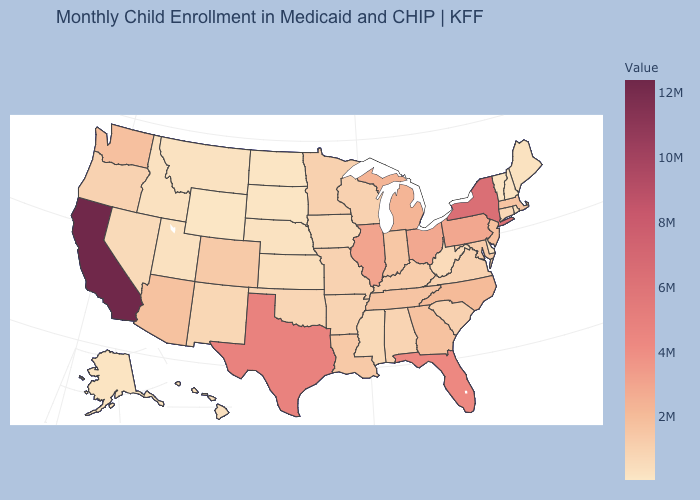Is the legend a continuous bar?
Give a very brief answer. Yes. Does Illinois have the highest value in the MidWest?
Keep it brief. Yes. Which states have the lowest value in the USA?
Quick response, please. Wyoming. Does Maine have a lower value than New Jersey?
Be succinct. Yes. Does Kentucky have the lowest value in the South?
Give a very brief answer. No. Does Arizona have the highest value in the USA?
Be succinct. No. Which states have the lowest value in the Northeast?
Be succinct. Vermont. Is the legend a continuous bar?
Concise answer only. Yes. Which states have the highest value in the USA?
Quick response, please. California. 